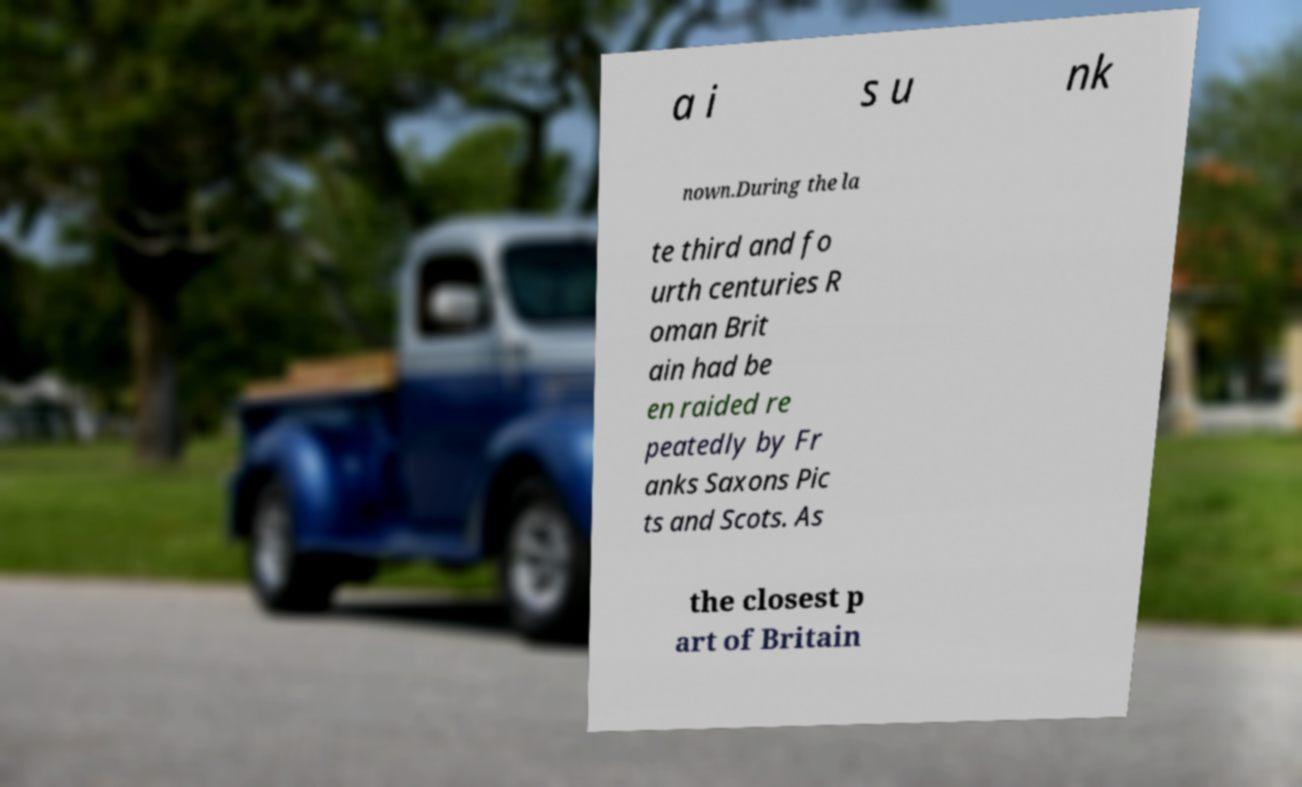For documentation purposes, I need the text within this image transcribed. Could you provide that? a i s u nk nown.During the la te third and fo urth centuries R oman Brit ain had be en raided re peatedly by Fr anks Saxons Pic ts and Scots. As the closest p art of Britain 